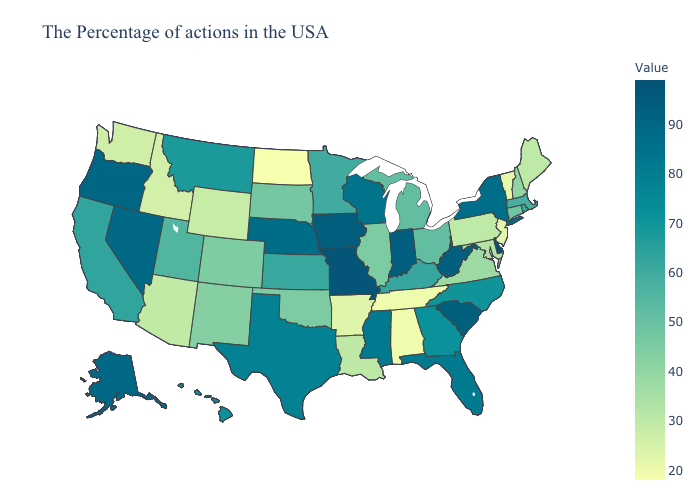Which states have the lowest value in the USA?
Short answer required. North Dakota. Which states have the highest value in the USA?
Write a very short answer. Delaware. Does Vermont have a higher value than Alaska?
Give a very brief answer. No. Which states have the highest value in the USA?
Answer briefly. Delaware. 